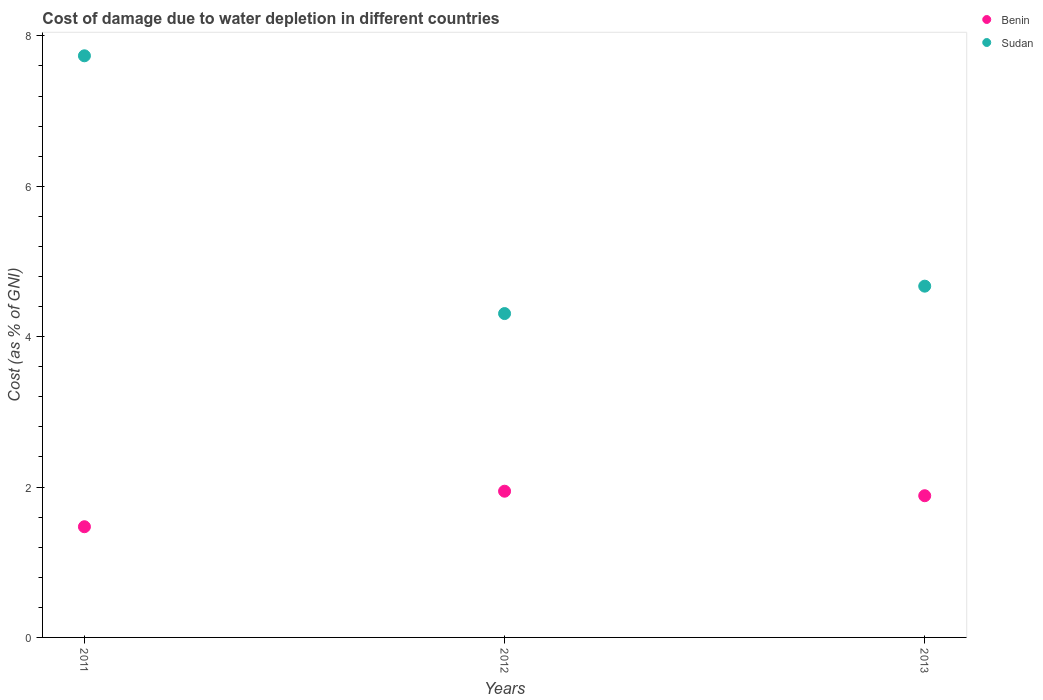What is the cost of damage caused due to water depletion in Sudan in 2013?
Provide a short and direct response. 4.67. Across all years, what is the maximum cost of damage caused due to water depletion in Benin?
Your answer should be very brief. 1.94. Across all years, what is the minimum cost of damage caused due to water depletion in Sudan?
Ensure brevity in your answer.  4.31. In which year was the cost of damage caused due to water depletion in Benin maximum?
Keep it short and to the point. 2012. In which year was the cost of damage caused due to water depletion in Benin minimum?
Provide a succinct answer. 2011. What is the total cost of damage caused due to water depletion in Benin in the graph?
Give a very brief answer. 5.3. What is the difference between the cost of damage caused due to water depletion in Benin in 2012 and that in 2013?
Make the answer very short. 0.06. What is the difference between the cost of damage caused due to water depletion in Sudan in 2013 and the cost of damage caused due to water depletion in Benin in 2012?
Provide a succinct answer. 2.73. What is the average cost of damage caused due to water depletion in Benin per year?
Your response must be concise. 1.77. In the year 2012, what is the difference between the cost of damage caused due to water depletion in Benin and cost of damage caused due to water depletion in Sudan?
Ensure brevity in your answer.  -2.36. In how many years, is the cost of damage caused due to water depletion in Sudan greater than 1.2000000000000002 %?
Give a very brief answer. 3. What is the ratio of the cost of damage caused due to water depletion in Sudan in 2012 to that in 2013?
Your response must be concise. 0.92. Is the cost of damage caused due to water depletion in Sudan in 2012 less than that in 2013?
Offer a very short reply. Yes. Is the difference between the cost of damage caused due to water depletion in Benin in 2012 and 2013 greater than the difference between the cost of damage caused due to water depletion in Sudan in 2012 and 2013?
Your answer should be very brief. Yes. What is the difference between the highest and the second highest cost of damage caused due to water depletion in Sudan?
Ensure brevity in your answer.  3.06. What is the difference between the highest and the lowest cost of damage caused due to water depletion in Benin?
Your response must be concise. 0.47. Is the sum of the cost of damage caused due to water depletion in Benin in 2011 and 2013 greater than the maximum cost of damage caused due to water depletion in Sudan across all years?
Your response must be concise. No. Is the cost of damage caused due to water depletion in Sudan strictly greater than the cost of damage caused due to water depletion in Benin over the years?
Your response must be concise. Yes. Is the cost of damage caused due to water depletion in Benin strictly less than the cost of damage caused due to water depletion in Sudan over the years?
Your response must be concise. Yes. How many dotlines are there?
Your response must be concise. 2. What is the difference between two consecutive major ticks on the Y-axis?
Your answer should be compact. 2. Where does the legend appear in the graph?
Keep it short and to the point. Top right. How many legend labels are there?
Ensure brevity in your answer.  2. How are the legend labels stacked?
Offer a terse response. Vertical. What is the title of the graph?
Provide a short and direct response. Cost of damage due to water depletion in different countries. Does "Burundi" appear as one of the legend labels in the graph?
Give a very brief answer. No. What is the label or title of the Y-axis?
Offer a terse response. Cost (as % of GNI). What is the Cost (as % of GNI) in Benin in 2011?
Your answer should be very brief. 1.47. What is the Cost (as % of GNI) of Sudan in 2011?
Your response must be concise. 7.73. What is the Cost (as % of GNI) of Benin in 2012?
Offer a terse response. 1.94. What is the Cost (as % of GNI) of Sudan in 2012?
Give a very brief answer. 4.31. What is the Cost (as % of GNI) of Benin in 2013?
Your answer should be very brief. 1.88. What is the Cost (as % of GNI) in Sudan in 2013?
Keep it short and to the point. 4.67. Across all years, what is the maximum Cost (as % of GNI) of Benin?
Provide a short and direct response. 1.94. Across all years, what is the maximum Cost (as % of GNI) of Sudan?
Your response must be concise. 7.73. Across all years, what is the minimum Cost (as % of GNI) in Benin?
Provide a succinct answer. 1.47. Across all years, what is the minimum Cost (as % of GNI) in Sudan?
Give a very brief answer. 4.31. What is the total Cost (as % of GNI) in Benin in the graph?
Your answer should be compact. 5.3. What is the total Cost (as % of GNI) of Sudan in the graph?
Offer a very short reply. 16.71. What is the difference between the Cost (as % of GNI) in Benin in 2011 and that in 2012?
Your response must be concise. -0.47. What is the difference between the Cost (as % of GNI) in Sudan in 2011 and that in 2012?
Keep it short and to the point. 3.43. What is the difference between the Cost (as % of GNI) in Benin in 2011 and that in 2013?
Offer a terse response. -0.41. What is the difference between the Cost (as % of GNI) in Sudan in 2011 and that in 2013?
Make the answer very short. 3.06. What is the difference between the Cost (as % of GNI) in Sudan in 2012 and that in 2013?
Offer a very short reply. -0.36. What is the difference between the Cost (as % of GNI) of Benin in 2011 and the Cost (as % of GNI) of Sudan in 2012?
Ensure brevity in your answer.  -2.83. What is the difference between the Cost (as % of GNI) of Benin in 2011 and the Cost (as % of GNI) of Sudan in 2013?
Offer a very short reply. -3.2. What is the difference between the Cost (as % of GNI) in Benin in 2012 and the Cost (as % of GNI) in Sudan in 2013?
Make the answer very short. -2.73. What is the average Cost (as % of GNI) of Benin per year?
Your answer should be very brief. 1.77. What is the average Cost (as % of GNI) of Sudan per year?
Offer a very short reply. 5.57. In the year 2011, what is the difference between the Cost (as % of GNI) in Benin and Cost (as % of GNI) in Sudan?
Offer a terse response. -6.26. In the year 2012, what is the difference between the Cost (as % of GNI) in Benin and Cost (as % of GNI) in Sudan?
Provide a succinct answer. -2.36. In the year 2013, what is the difference between the Cost (as % of GNI) of Benin and Cost (as % of GNI) of Sudan?
Give a very brief answer. -2.79. What is the ratio of the Cost (as % of GNI) of Benin in 2011 to that in 2012?
Keep it short and to the point. 0.76. What is the ratio of the Cost (as % of GNI) of Sudan in 2011 to that in 2012?
Offer a terse response. 1.8. What is the ratio of the Cost (as % of GNI) of Benin in 2011 to that in 2013?
Provide a succinct answer. 0.78. What is the ratio of the Cost (as % of GNI) of Sudan in 2011 to that in 2013?
Your answer should be compact. 1.66. What is the ratio of the Cost (as % of GNI) of Benin in 2012 to that in 2013?
Offer a very short reply. 1.03. What is the ratio of the Cost (as % of GNI) of Sudan in 2012 to that in 2013?
Provide a succinct answer. 0.92. What is the difference between the highest and the second highest Cost (as % of GNI) of Benin?
Make the answer very short. 0.06. What is the difference between the highest and the second highest Cost (as % of GNI) in Sudan?
Offer a terse response. 3.06. What is the difference between the highest and the lowest Cost (as % of GNI) of Benin?
Provide a short and direct response. 0.47. What is the difference between the highest and the lowest Cost (as % of GNI) in Sudan?
Offer a terse response. 3.43. 